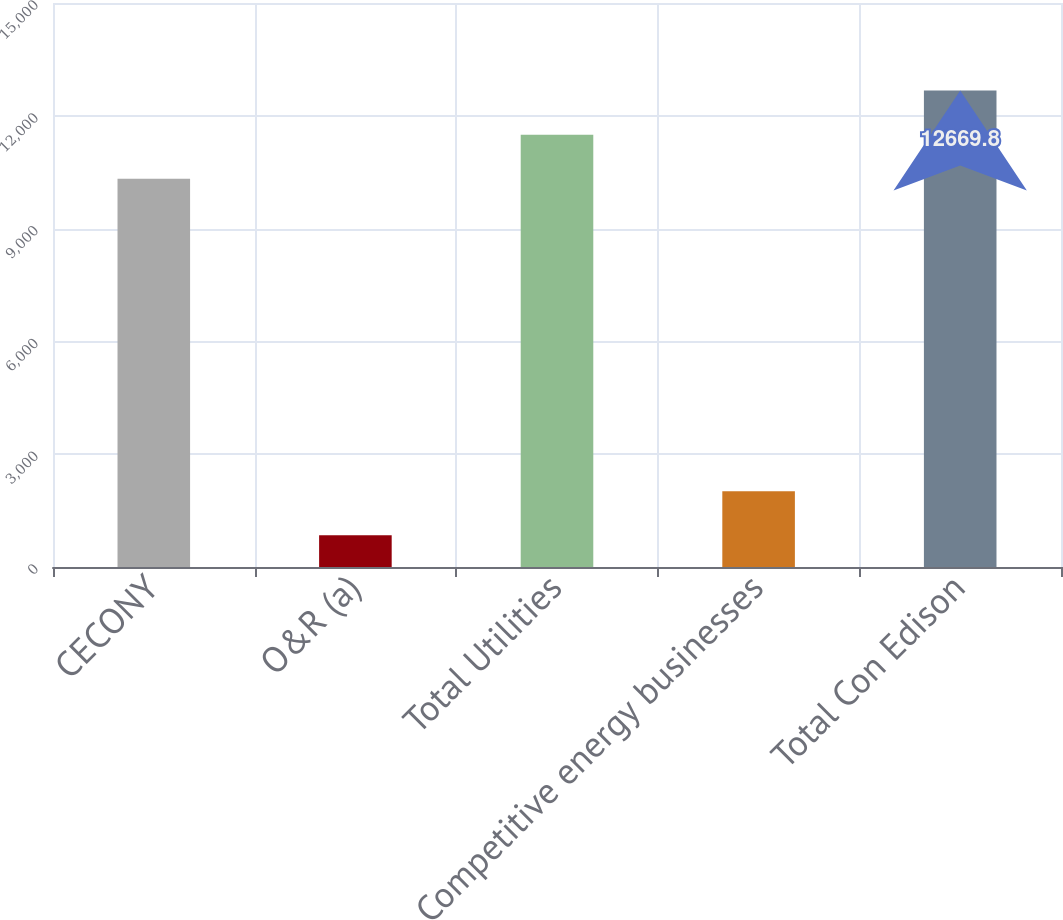<chart> <loc_0><loc_0><loc_500><loc_500><bar_chart><fcel>CECONY<fcel>O&R (a)<fcel>Total Utilities<fcel>Competitive energy businesses<fcel>Total Con Edison<nl><fcel>10328<fcel>845<fcel>11498.9<fcel>2015.9<fcel>12669.8<nl></chart> 